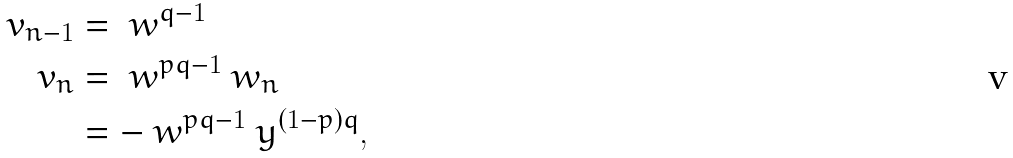<formula> <loc_0><loc_0><loc_500><loc_500>v _ { n - 1 } & = \ w ^ { q - 1 } \\ v _ { n } & = \ w ^ { p q - 1 } \ w _ { n } \\ & = - \ w ^ { p q - 1 } \ y ^ { ( 1 - p ) q } ,</formula> 